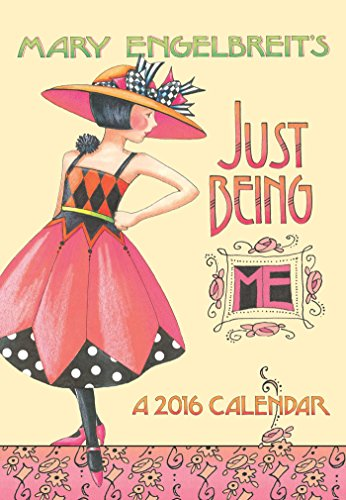Which year's calendar is this? This pocket planner is designed for the year 2016, as reflected in the title and the artistic designs denoting key holidays and dates for that particular year. 